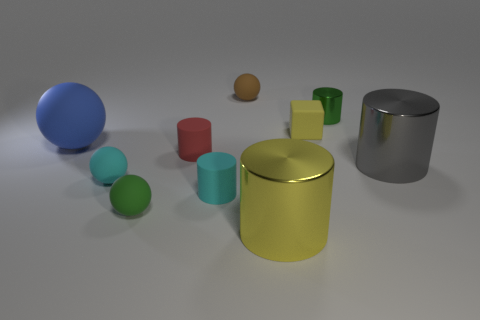There is a yellow thing behind the small red thing; does it have the same shape as the big gray object? The yellow object in question appears to be a cylindrical shape, as is the large gray object. However, while they share the characteristic of being cylinders, there are distinct differences. The yellow cylinder is shorter and has no visible hollow section or cutout, unlike the gray cylinder, which has a significant portion visibly cut away. In essence, they have similar basic geometric forms but differ in their specific dimensions and features. 